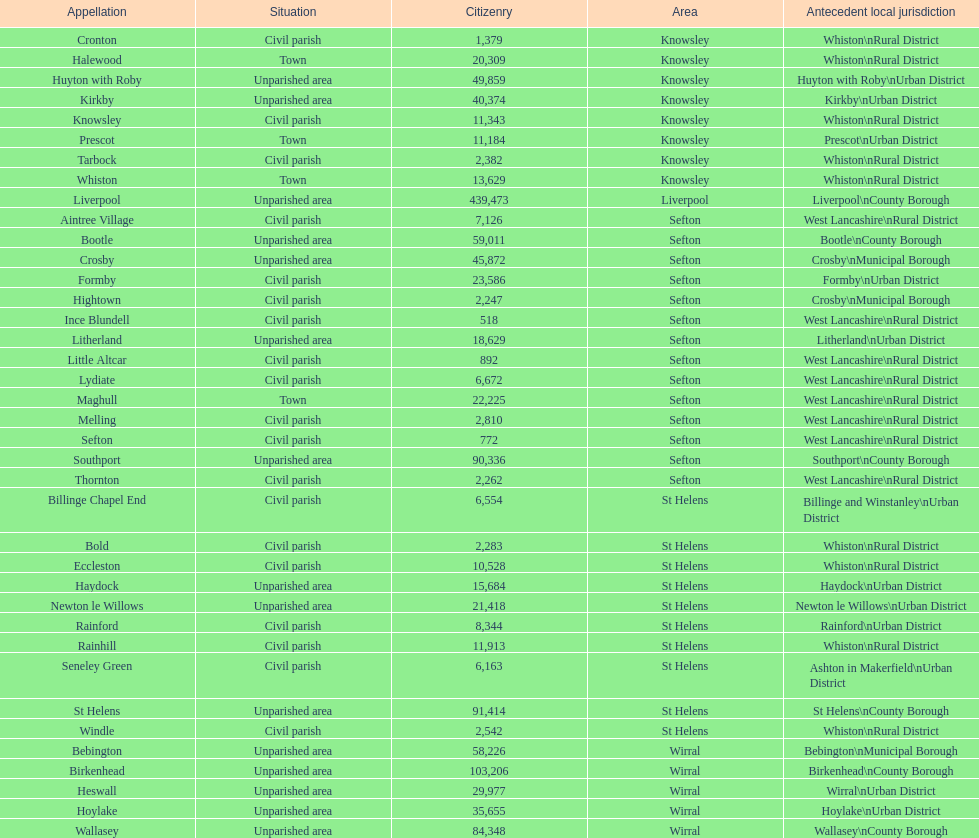How many areas are unparished areas? 15. 